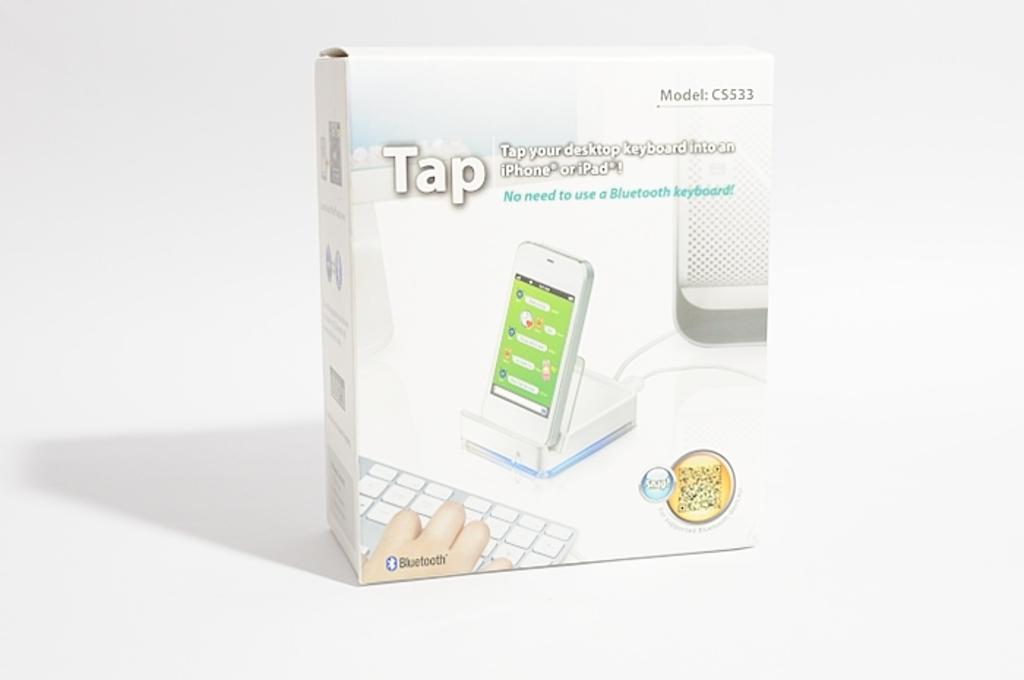<image>
Offer a succinct explanation of the picture presented. An item called Tap can be used to turn your desktop keyboard into an iPhone. 